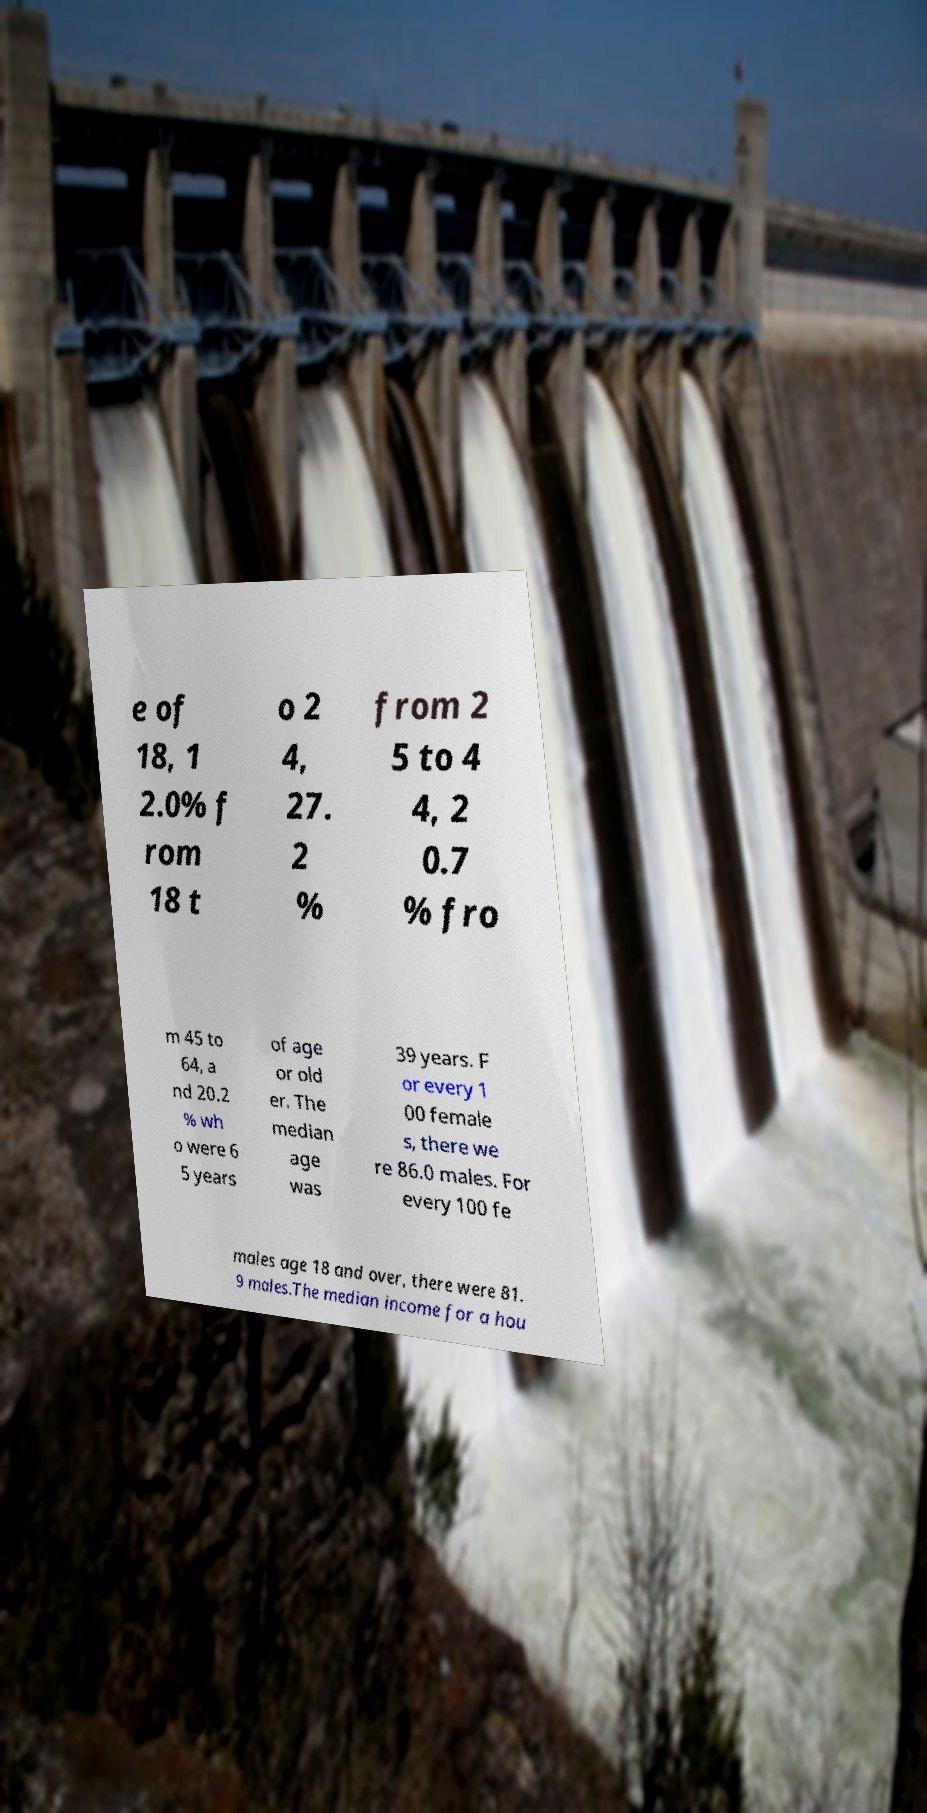Can you accurately transcribe the text from the provided image for me? e of 18, 1 2.0% f rom 18 t o 2 4, 27. 2 % from 2 5 to 4 4, 2 0.7 % fro m 45 to 64, a nd 20.2 % wh o were 6 5 years of age or old er. The median age was 39 years. F or every 1 00 female s, there we re 86.0 males. For every 100 fe males age 18 and over, there were 81. 9 males.The median income for a hou 